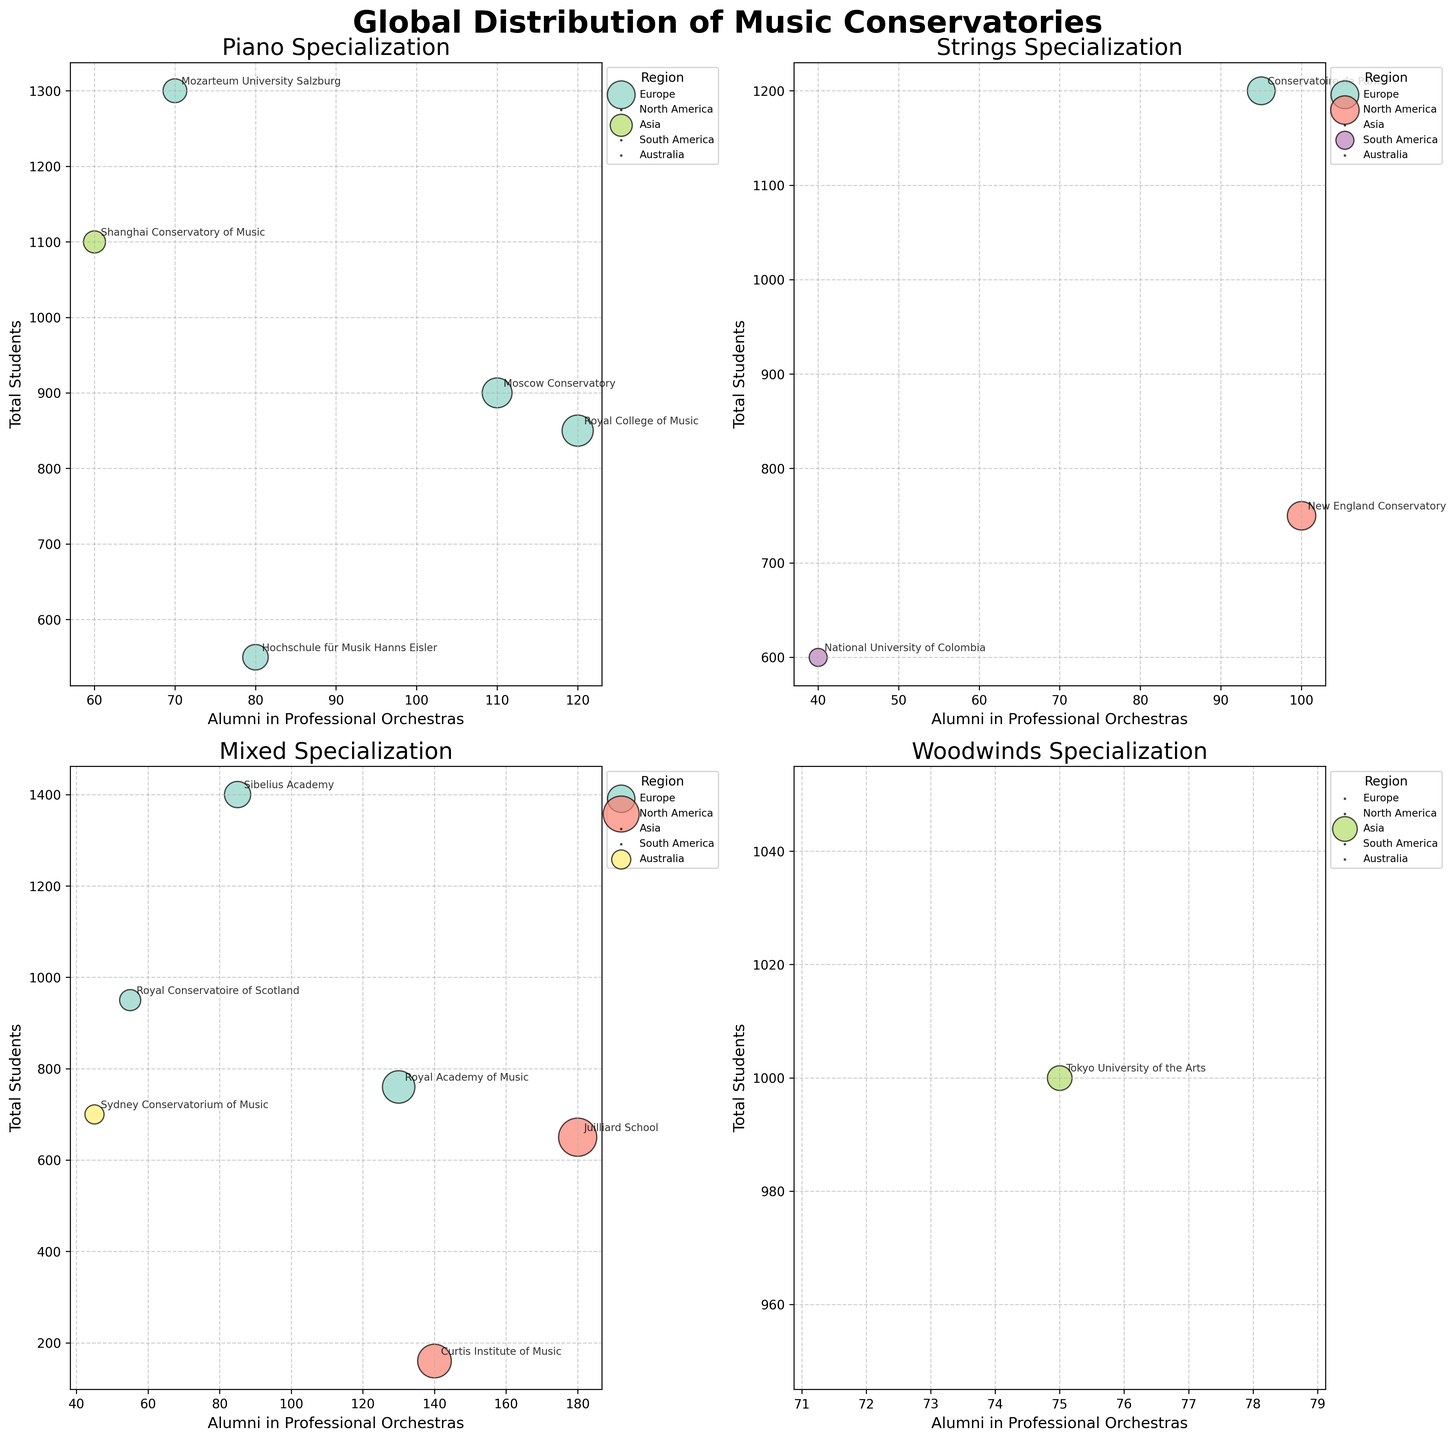What is the title of the whole figure? The title of the figure is prominently displayed at the top center. It reads "Global Distribution of Music Conservatories."
Answer: Global Distribution of Music Conservatories How many subplots are in the figure? The figure is organized into four subplots, arranged in a 2x2 grid. Each subplot corresponds to a different musical specialization.
Answer: 4 Which region has the most conservatories listed in the "Piano Specialization" subplot? By examining the "Piano Specialization" subplot, Europe has three conservatories labeled: Royal College of Music, Moscow Conservatory, and Hochschule für Musik Hanns Eisler.
Answer: Europe Which conservatory from North America has the highest number of alumni in professional orchestras and what is the total number of its students? Looking at the "Mixed Specialization" subplot, the Juilliard School from North America has the highest number of alumni in professional orchestras at 180, with a total of 650 students.
Answer: Juilliard School, 650 Among the conservatories in Asia, which one specializes in "Woodwinds," and how many alumni does it have in professional orchestras? The "Woodwinds Specialization" subplot displays the Tokyo University of the Arts with 75 alumni in professional orchestras.
Answer: Tokyo University of the Arts, 75 What is the average number of total students for European conservatories specializing in "Strings"? The European conservatories specializing in "Strings" are Conservatoire de Paris with 1200 students and Royal Conservatory of Scotland with 950 students. Adding these gives 2150. Dividing by the number of conservatories (2) gives: 2150/2 = 1075.
Answer: 1075 Which specialization has the conservatory with the highest number of alumni in professional orchestras, and which conservatory is it? The "Mixed Specialization" subplot features Juilliard School with 180 alumni in professional orchestras, higher than any other conservatory.
Answer: Mixed, Juilliard School How does the number of alumni in professional orchestras at the Royal Academy of Music compare to those at the Curtis Institute of Music? Within the "Mixed Specialization" subplot, the Royal Academy of Music has 130 alumni, while the Curtis Institute of Music has 140. Curtis Institute of Music has more alumni in professional orchestras.
Answer: Curtis Institute of Music What is the total number of students for all conservatories specializing in "Piano"? The "Piano Specialization" subplot includes Royal College of Music (850), Moscow Conservatory (900), Shanghai Conservatory of Music (1100), and Hochschule für Musik Hanns Eisler (550). Adding these together: 850 + 900 + 1100 + 550 = 3400.
Answer: 3400 